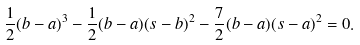<formula> <loc_0><loc_0><loc_500><loc_500>\frac { 1 } { 2 } ( b - a ) ^ { 3 } - \frac { 1 } { 2 } ( b - a ) ( s - b ) ^ { 2 } - \frac { 7 } { 2 } ( b - a ) ( s - a ) ^ { 2 } = 0 .</formula> 